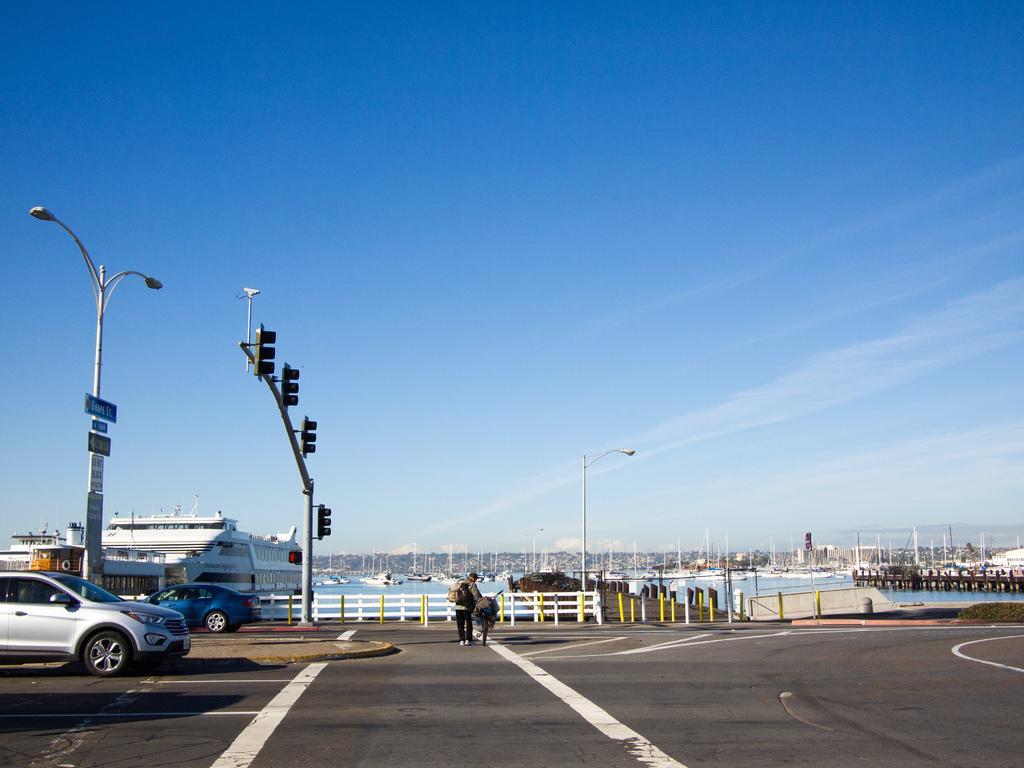Describe this image in one or two sentences. There is a road. On that a person wearing bag is holding a cycle. On the left side there are vehicles. In the back there is a railing, poles. Also there are street light pole with boards, traffic light poles. In the background there is water, sky with clouds. Also there is a boat. 